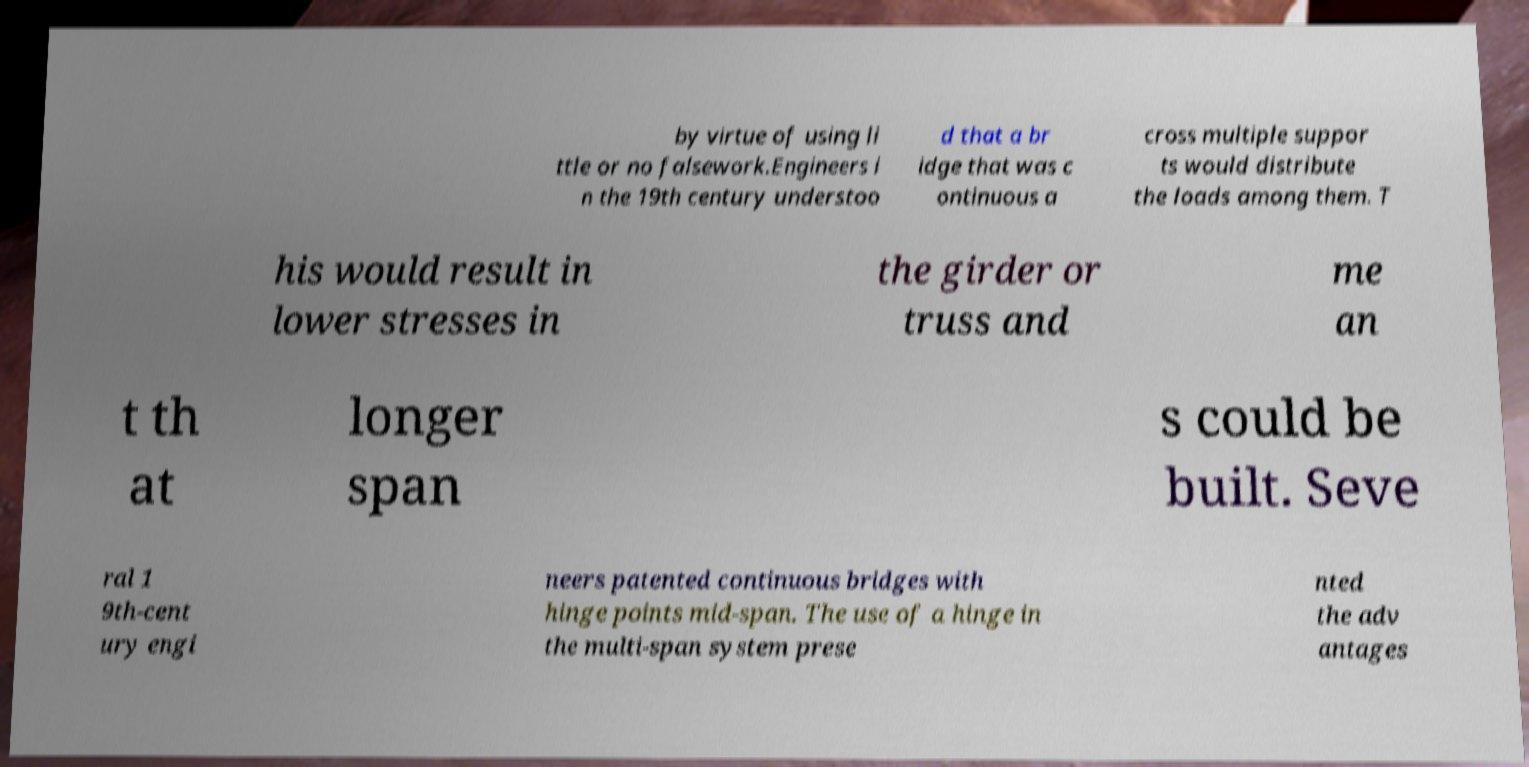Could you extract and type out the text from this image? by virtue of using li ttle or no falsework.Engineers i n the 19th century understoo d that a br idge that was c ontinuous a cross multiple suppor ts would distribute the loads among them. T his would result in lower stresses in the girder or truss and me an t th at longer span s could be built. Seve ral 1 9th-cent ury engi neers patented continuous bridges with hinge points mid-span. The use of a hinge in the multi-span system prese nted the adv antages 